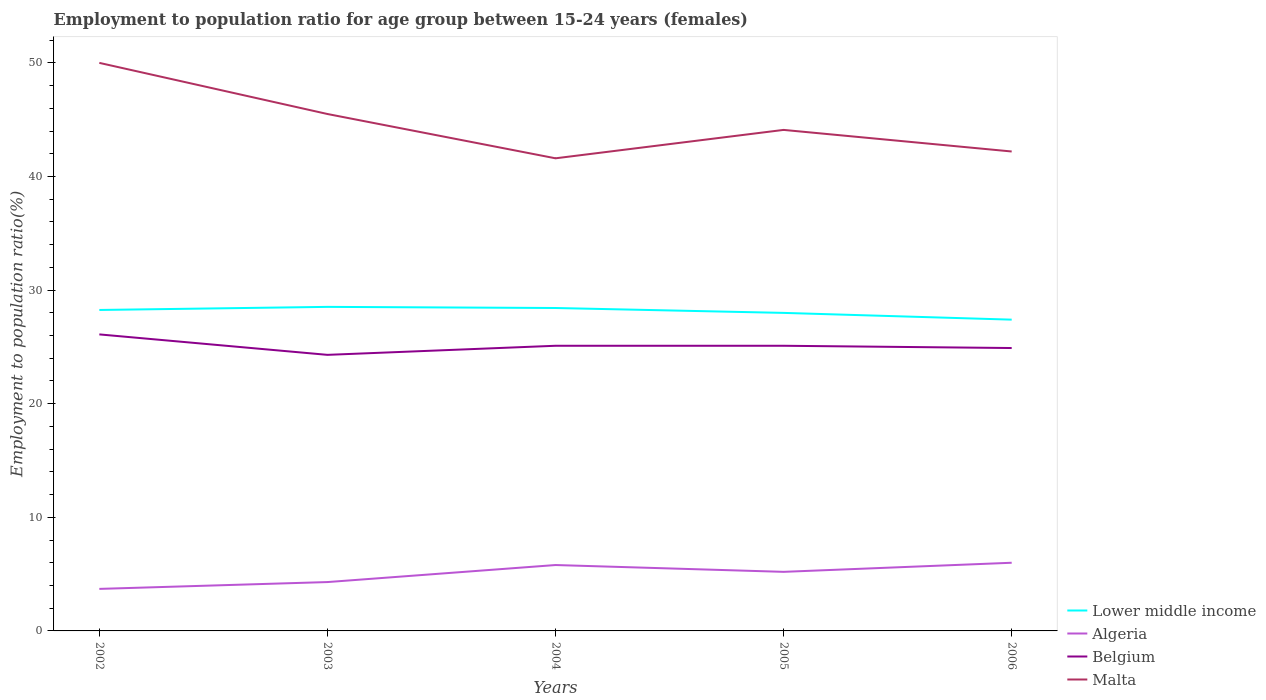How many different coloured lines are there?
Your response must be concise. 4. Across all years, what is the maximum employment to population ratio in Malta?
Keep it short and to the point. 41.6. In which year was the employment to population ratio in Belgium maximum?
Your answer should be compact. 2003. What is the total employment to population ratio in Belgium in the graph?
Offer a terse response. -0.8. What is the difference between the highest and the second highest employment to population ratio in Lower middle income?
Ensure brevity in your answer.  1.12. What is the difference between the highest and the lowest employment to population ratio in Malta?
Provide a succinct answer. 2. Is the employment to population ratio in Belgium strictly greater than the employment to population ratio in Algeria over the years?
Offer a very short reply. No. How many lines are there?
Keep it short and to the point. 4. What is the difference between two consecutive major ticks on the Y-axis?
Give a very brief answer. 10. Are the values on the major ticks of Y-axis written in scientific E-notation?
Keep it short and to the point. No. Does the graph contain any zero values?
Provide a short and direct response. No. Does the graph contain grids?
Offer a terse response. No. How many legend labels are there?
Your answer should be compact. 4. What is the title of the graph?
Make the answer very short. Employment to population ratio for age group between 15-24 years (females). What is the label or title of the X-axis?
Your response must be concise. Years. What is the label or title of the Y-axis?
Your answer should be very brief. Employment to population ratio(%). What is the Employment to population ratio(%) in Lower middle income in 2002?
Offer a terse response. 28.25. What is the Employment to population ratio(%) of Algeria in 2002?
Your answer should be very brief. 3.7. What is the Employment to population ratio(%) of Belgium in 2002?
Your response must be concise. 26.1. What is the Employment to population ratio(%) in Malta in 2002?
Your answer should be very brief. 50. What is the Employment to population ratio(%) of Lower middle income in 2003?
Offer a very short reply. 28.52. What is the Employment to population ratio(%) in Algeria in 2003?
Make the answer very short. 4.3. What is the Employment to population ratio(%) in Belgium in 2003?
Your response must be concise. 24.3. What is the Employment to population ratio(%) in Malta in 2003?
Your response must be concise. 45.5. What is the Employment to population ratio(%) of Lower middle income in 2004?
Make the answer very short. 28.42. What is the Employment to population ratio(%) of Algeria in 2004?
Offer a terse response. 5.8. What is the Employment to population ratio(%) in Belgium in 2004?
Keep it short and to the point. 25.1. What is the Employment to population ratio(%) of Malta in 2004?
Ensure brevity in your answer.  41.6. What is the Employment to population ratio(%) of Lower middle income in 2005?
Give a very brief answer. 27.99. What is the Employment to population ratio(%) of Algeria in 2005?
Your response must be concise. 5.2. What is the Employment to population ratio(%) in Belgium in 2005?
Your answer should be very brief. 25.1. What is the Employment to population ratio(%) in Malta in 2005?
Offer a terse response. 44.1. What is the Employment to population ratio(%) of Lower middle income in 2006?
Provide a short and direct response. 27.4. What is the Employment to population ratio(%) of Algeria in 2006?
Offer a very short reply. 6. What is the Employment to population ratio(%) of Belgium in 2006?
Ensure brevity in your answer.  24.9. What is the Employment to population ratio(%) of Malta in 2006?
Ensure brevity in your answer.  42.2. Across all years, what is the maximum Employment to population ratio(%) in Lower middle income?
Provide a succinct answer. 28.52. Across all years, what is the maximum Employment to population ratio(%) of Belgium?
Offer a terse response. 26.1. Across all years, what is the minimum Employment to population ratio(%) of Lower middle income?
Your answer should be very brief. 27.4. Across all years, what is the minimum Employment to population ratio(%) in Algeria?
Your answer should be compact. 3.7. Across all years, what is the minimum Employment to population ratio(%) in Belgium?
Provide a short and direct response. 24.3. Across all years, what is the minimum Employment to population ratio(%) of Malta?
Your answer should be very brief. 41.6. What is the total Employment to population ratio(%) in Lower middle income in the graph?
Offer a terse response. 140.59. What is the total Employment to population ratio(%) in Belgium in the graph?
Keep it short and to the point. 125.5. What is the total Employment to population ratio(%) of Malta in the graph?
Provide a succinct answer. 223.4. What is the difference between the Employment to population ratio(%) of Lower middle income in 2002 and that in 2003?
Offer a terse response. -0.27. What is the difference between the Employment to population ratio(%) in Malta in 2002 and that in 2003?
Provide a short and direct response. 4.5. What is the difference between the Employment to population ratio(%) in Lower middle income in 2002 and that in 2004?
Your answer should be compact. -0.17. What is the difference between the Employment to population ratio(%) of Algeria in 2002 and that in 2004?
Provide a succinct answer. -2.1. What is the difference between the Employment to population ratio(%) in Belgium in 2002 and that in 2004?
Provide a short and direct response. 1. What is the difference between the Employment to population ratio(%) in Lower middle income in 2002 and that in 2005?
Make the answer very short. 0.26. What is the difference between the Employment to population ratio(%) in Lower middle income in 2002 and that in 2006?
Offer a very short reply. 0.85. What is the difference between the Employment to population ratio(%) in Algeria in 2002 and that in 2006?
Your answer should be compact. -2.3. What is the difference between the Employment to population ratio(%) of Belgium in 2002 and that in 2006?
Make the answer very short. 1.2. What is the difference between the Employment to population ratio(%) in Lower middle income in 2003 and that in 2004?
Offer a very short reply. 0.1. What is the difference between the Employment to population ratio(%) of Belgium in 2003 and that in 2004?
Your answer should be very brief. -0.8. What is the difference between the Employment to population ratio(%) of Lower middle income in 2003 and that in 2005?
Ensure brevity in your answer.  0.53. What is the difference between the Employment to population ratio(%) of Belgium in 2003 and that in 2005?
Provide a succinct answer. -0.8. What is the difference between the Employment to population ratio(%) in Lower middle income in 2003 and that in 2006?
Offer a terse response. 1.12. What is the difference between the Employment to population ratio(%) in Lower middle income in 2004 and that in 2005?
Ensure brevity in your answer.  0.43. What is the difference between the Employment to population ratio(%) in Belgium in 2004 and that in 2005?
Provide a succinct answer. 0. What is the difference between the Employment to population ratio(%) of Malta in 2004 and that in 2005?
Provide a short and direct response. -2.5. What is the difference between the Employment to population ratio(%) of Lower middle income in 2004 and that in 2006?
Your answer should be very brief. 1.02. What is the difference between the Employment to population ratio(%) of Malta in 2004 and that in 2006?
Ensure brevity in your answer.  -0.6. What is the difference between the Employment to population ratio(%) in Lower middle income in 2005 and that in 2006?
Keep it short and to the point. 0.59. What is the difference between the Employment to population ratio(%) in Algeria in 2005 and that in 2006?
Your response must be concise. -0.8. What is the difference between the Employment to population ratio(%) in Belgium in 2005 and that in 2006?
Make the answer very short. 0.2. What is the difference between the Employment to population ratio(%) of Malta in 2005 and that in 2006?
Your answer should be compact. 1.9. What is the difference between the Employment to population ratio(%) in Lower middle income in 2002 and the Employment to population ratio(%) in Algeria in 2003?
Your response must be concise. 23.95. What is the difference between the Employment to population ratio(%) in Lower middle income in 2002 and the Employment to population ratio(%) in Belgium in 2003?
Keep it short and to the point. 3.95. What is the difference between the Employment to population ratio(%) of Lower middle income in 2002 and the Employment to population ratio(%) of Malta in 2003?
Your answer should be compact. -17.25. What is the difference between the Employment to population ratio(%) in Algeria in 2002 and the Employment to population ratio(%) in Belgium in 2003?
Offer a terse response. -20.6. What is the difference between the Employment to population ratio(%) of Algeria in 2002 and the Employment to population ratio(%) of Malta in 2003?
Keep it short and to the point. -41.8. What is the difference between the Employment to population ratio(%) in Belgium in 2002 and the Employment to population ratio(%) in Malta in 2003?
Keep it short and to the point. -19.4. What is the difference between the Employment to population ratio(%) in Lower middle income in 2002 and the Employment to population ratio(%) in Algeria in 2004?
Give a very brief answer. 22.45. What is the difference between the Employment to population ratio(%) of Lower middle income in 2002 and the Employment to population ratio(%) of Belgium in 2004?
Provide a short and direct response. 3.15. What is the difference between the Employment to population ratio(%) in Lower middle income in 2002 and the Employment to population ratio(%) in Malta in 2004?
Ensure brevity in your answer.  -13.35. What is the difference between the Employment to population ratio(%) in Algeria in 2002 and the Employment to population ratio(%) in Belgium in 2004?
Offer a terse response. -21.4. What is the difference between the Employment to population ratio(%) of Algeria in 2002 and the Employment to population ratio(%) of Malta in 2004?
Offer a very short reply. -37.9. What is the difference between the Employment to population ratio(%) in Belgium in 2002 and the Employment to population ratio(%) in Malta in 2004?
Make the answer very short. -15.5. What is the difference between the Employment to population ratio(%) of Lower middle income in 2002 and the Employment to population ratio(%) of Algeria in 2005?
Keep it short and to the point. 23.05. What is the difference between the Employment to population ratio(%) in Lower middle income in 2002 and the Employment to population ratio(%) in Belgium in 2005?
Your answer should be very brief. 3.15. What is the difference between the Employment to population ratio(%) of Lower middle income in 2002 and the Employment to population ratio(%) of Malta in 2005?
Give a very brief answer. -15.85. What is the difference between the Employment to population ratio(%) in Algeria in 2002 and the Employment to population ratio(%) in Belgium in 2005?
Offer a very short reply. -21.4. What is the difference between the Employment to population ratio(%) of Algeria in 2002 and the Employment to population ratio(%) of Malta in 2005?
Provide a short and direct response. -40.4. What is the difference between the Employment to population ratio(%) in Lower middle income in 2002 and the Employment to population ratio(%) in Algeria in 2006?
Your answer should be compact. 22.25. What is the difference between the Employment to population ratio(%) of Lower middle income in 2002 and the Employment to population ratio(%) of Belgium in 2006?
Offer a very short reply. 3.35. What is the difference between the Employment to population ratio(%) of Lower middle income in 2002 and the Employment to population ratio(%) of Malta in 2006?
Provide a short and direct response. -13.95. What is the difference between the Employment to population ratio(%) of Algeria in 2002 and the Employment to population ratio(%) of Belgium in 2006?
Your answer should be very brief. -21.2. What is the difference between the Employment to population ratio(%) in Algeria in 2002 and the Employment to population ratio(%) in Malta in 2006?
Ensure brevity in your answer.  -38.5. What is the difference between the Employment to population ratio(%) in Belgium in 2002 and the Employment to population ratio(%) in Malta in 2006?
Keep it short and to the point. -16.1. What is the difference between the Employment to population ratio(%) of Lower middle income in 2003 and the Employment to population ratio(%) of Algeria in 2004?
Your answer should be compact. 22.72. What is the difference between the Employment to population ratio(%) of Lower middle income in 2003 and the Employment to population ratio(%) of Belgium in 2004?
Offer a very short reply. 3.42. What is the difference between the Employment to population ratio(%) in Lower middle income in 2003 and the Employment to population ratio(%) in Malta in 2004?
Your answer should be very brief. -13.08. What is the difference between the Employment to population ratio(%) of Algeria in 2003 and the Employment to population ratio(%) of Belgium in 2004?
Keep it short and to the point. -20.8. What is the difference between the Employment to population ratio(%) in Algeria in 2003 and the Employment to population ratio(%) in Malta in 2004?
Your answer should be compact. -37.3. What is the difference between the Employment to population ratio(%) in Belgium in 2003 and the Employment to population ratio(%) in Malta in 2004?
Ensure brevity in your answer.  -17.3. What is the difference between the Employment to population ratio(%) of Lower middle income in 2003 and the Employment to population ratio(%) of Algeria in 2005?
Ensure brevity in your answer.  23.32. What is the difference between the Employment to population ratio(%) of Lower middle income in 2003 and the Employment to population ratio(%) of Belgium in 2005?
Your answer should be compact. 3.42. What is the difference between the Employment to population ratio(%) of Lower middle income in 2003 and the Employment to population ratio(%) of Malta in 2005?
Offer a terse response. -15.58. What is the difference between the Employment to population ratio(%) of Algeria in 2003 and the Employment to population ratio(%) of Belgium in 2005?
Ensure brevity in your answer.  -20.8. What is the difference between the Employment to population ratio(%) in Algeria in 2003 and the Employment to population ratio(%) in Malta in 2005?
Make the answer very short. -39.8. What is the difference between the Employment to population ratio(%) in Belgium in 2003 and the Employment to population ratio(%) in Malta in 2005?
Ensure brevity in your answer.  -19.8. What is the difference between the Employment to population ratio(%) in Lower middle income in 2003 and the Employment to population ratio(%) in Algeria in 2006?
Keep it short and to the point. 22.52. What is the difference between the Employment to population ratio(%) in Lower middle income in 2003 and the Employment to population ratio(%) in Belgium in 2006?
Offer a very short reply. 3.62. What is the difference between the Employment to population ratio(%) of Lower middle income in 2003 and the Employment to population ratio(%) of Malta in 2006?
Keep it short and to the point. -13.68. What is the difference between the Employment to population ratio(%) of Algeria in 2003 and the Employment to population ratio(%) of Belgium in 2006?
Provide a succinct answer. -20.6. What is the difference between the Employment to population ratio(%) of Algeria in 2003 and the Employment to population ratio(%) of Malta in 2006?
Your answer should be very brief. -37.9. What is the difference between the Employment to population ratio(%) in Belgium in 2003 and the Employment to population ratio(%) in Malta in 2006?
Make the answer very short. -17.9. What is the difference between the Employment to population ratio(%) in Lower middle income in 2004 and the Employment to population ratio(%) in Algeria in 2005?
Ensure brevity in your answer.  23.22. What is the difference between the Employment to population ratio(%) in Lower middle income in 2004 and the Employment to population ratio(%) in Belgium in 2005?
Ensure brevity in your answer.  3.32. What is the difference between the Employment to population ratio(%) in Lower middle income in 2004 and the Employment to population ratio(%) in Malta in 2005?
Make the answer very short. -15.68. What is the difference between the Employment to population ratio(%) in Algeria in 2004 and the Employment to population ratio(%) in Belgium in 2005?
Provide a succinct answer. -19.3. What is the difference between the Employment to population ratio(%) in Algeria in 2004 and the Employment to population ratio(%) in Malta in 2005?
Keep it short and to the point. -38.3. What is the difference between the Employment to population ratio(%) of Belgium in 2004 and the Employment to population ratio(%) of Malta in 2005?
Provide a short and direct response. -19. What is the difference between the Employment to population ratio(%) of Lower middle income in 2004 and the Employment to population ratio(%) of Algeria in 2006?
Provide a short and direct response. 22.42. What is the difference between the Employment to population ratio(%) of Lower middle income in 2004 and the Employment to population ratio(%) of Belgium in 2006?
Ensure brevity in your answer.  3.52. What is the difference between the Employment to population ratio(%) of Lower middle income in 2004 and the Employment to population ratio(%) of Malta in 2006?
Keep it short and to the point. -13.78. What is the difference between the Employment to population ratio(%) of Algeria in 2004 and the Employment to population ratio(%) of Belgium in 2006?
Provide a succinct answer. -19.1. What is the difference between the Employment to population ratio(%) in Algeria in 2004 and the Employment to population ratio(%) in Malta in 2006?
Your response must be concise. -36.4. What is the difference between the Employment to population ratio(%) in Belgium in 2004 and the Employment to population ratio(%) in Malta in 2006?
Offer a terse response. -17.1. What is the difference between the Employment to population ratio(%) of Lower middle income in 2005 and the Employment to population ratio(%) of Algeria in 2006?
Your answer should be very brief. 21.99. What is the difference between the Employment to population ratio(%) in Lower middle income in 2005 and the Employment to population ratio(%) in Belgium in 2006?
Make the answer very short. 3.09. What is the difference between the Employment to population ratio(%) in Lower middle income in 2005 and the Employment to population ratio(%) in Malta in 2006?
Offer a very short reply. -14.21. What is the difference between the Employment to population ratio(%) in Algeria in 2005 and the Employment to population ratio(%) in Belgium in 2006?
Your answer should be very brief. -19.7. What is the difference between the Employment to population ratio(%) in Algeria in 2005 and the Employment to population ratio(%) in Malta in 2006?
Your response must be concise. -37. What is the difference between the Employment to population ratio(%) of Belgium in 2005 and the Employment to population ratio(%) of Malta in 2006?
Offer a very short reply. -17.1. What is the average Employment to population ratio(%) of Lower middle income per year?
Offer a very short reply. 28.12. What is the average Employment to population ratio(%) of Belgium per year?
Your answer should be compact. 25.1. What is the average Employment to population ratio(%) of Malta per year?
Offer a terse response. 44.68. In the year 2002, what is the difference between the Employment to population ratio(%) in Lower middle income and Employment to population ratio(%) in Algeria?
Provide a short and direct response. 24.55. In the year 2002, what is the difference between the Employment to population ratio(%) in Lower middle income and Employment to population ratio(%) in Belgium?
Make the answer very short. 2.15. In the year 2002, what is the difference between the Employment to population ratio(%) of Lower middle income and Employment to population ratio(%) of Malta?
Provide a succinct answer. -21.75. In the year 2002, what is the difference between the Employment to population ratio(%) of Algeria and Employment to population ratio(%) of Belgium?
Offer a terse response. -22.4. In the year 2002, what is the difference between the Employment to population ratio(%) in Algeria and Employment to population ratio(%) in Malta?
Make the answer very short. -46.3. In the year 2002, what is the difference between the Employment to population ratio(%) of Belgium and Employment to population ratio(%) of Malta?
Ensure brevity in your answer.  -23.9. In the year 2003, what is the difference between the Employment to population ratio(%) of Lower middle income and Employment to population ratio(%) of Algeria?
Ensure brevity in your answer.  24.22. In the year 2003, what is the difference between the Employment to population ratio(%) in Lower middle income and Employment to population ratio(%) in Belgium?
Ensure brevity in your answer.  4.22. In the year 2003, what is the difference between the Employment to population ratio(%) of Lower middle income and Employment to population ratio(%) of Malta?
Offer a terse response. -16.98. In the year 2003, what is the difference between the Employment to population ratio(%) of Algeria and Employment to population ratio(%) of Malta?
Offer a terse response. -41.2. In the year 2003, what is the difference between the Employment to population ratio(%) in Belgium and Employment to population ratio(%) in Malta?
Your response must be concise. -21.2. In the year 2004, what is the difference between the Employment to population ratio(%) in Lower middle income and Employment to population ratio(%) in Algeria?
Your response must be concise. 22.62. In the year 2004, what is the difference between the Employment to population ratio(%) of Lower middle income and Employment to population ratio(%) of Belgium?
Provide a succinct answer. 3.32. In the year 2004, what is the difference between the Employment to population ratio(%) of Lower middle income and Employment to population ratio(%) of Malta?
Offer a very short reply. -13.18. In the year 2004, what is the difference between the Employment to population ratio(%) in Algeria and Employment to population ratio(%) in Belgium?
Your response must be concise. -19.3. In the year 2004, what is the difference between the Employment to population ratio(%) in Algeria and Employment to population ratio(%) in Malta?
Keep it short and to the point. -35.8. In the year 2004, what is the difference between the Employment to population ratio(%) of Belgium and Employment to population ratio(%) of Malta?
Your response must be concise. -16.5. In the year 2005, what is the difference between the Employment to population ratio(%) in Lower middle income and Employment to population ratio(%) in Algeria?
Offer a terse response. 22.79. In the year 2005, what is the difference between the Employment to population ratio(%) of Lower middle income and Employment to population ratio(%) of Belgium?
Give a very brief answer. 2.89. In the year 2005, what is the difference between the Employment to population ratio(%) in Lower middle income and Employment to population ratio(%) in Malta?
Give a very brief answer. -16.11. In the year 2005, what is the difference between the Employment to population ratio(%) in Algeria and Employment to population ratio(%) in Belgium?
Provide a succinct answer. -19.9. In the year 2005, what is the difference between the Employment to population ratio(%) in Algeria and Employment to population ratio(%) in Malta?
Provide a short and direct response. -38.9. In the year 2006, what is the difference between the Employment to population ratio(%) of Lower middle income and Employment to population ratio(%) of Algeria?
Offer a very short reply. 21.4. In the year 2006, what is the difference between the Employment to population ratio(%) of Lower middle income and Employment to population ratio(%) of Belgium?
Provide a succinct answer. 2.5. In the year 2006, what is the difference between the Employment to population ratio(%) in Lower middle income and Employment to population ratio(%) in Malta?
Ensure brevity in your answer.  -14.8. In the year 2006, what is the difference between the Employment to population ratio(%) in Algeria and Employment to population ratio(%) in Belgium?
Your response must be concise. -18.9. In the year 2006, what is the difference between the Employment to population ratio(%) of Algeria and Employment to population ratio(%) of Malta?
Your answer should be very brief. -36.2. In the year 2006, what is the difference between the Employment to population ratio(%) of Belgium and Employment to population ratio(%) of Malta?
Keep it short and to the point. -17.3. What is the ratio of the Employment to population ratio(%) in Lower middle income in 2002 to that in 2003?
Your answer should be compact. 0.99. What is the ratio of the Employment to population ratio(%) of Algeria in 2002 to that in 2003?
Give a very brief answer. 0.86. What is the ratio of the Employment to population ratio(%) of Belgium in 2002 to that in 2003?
Keep it short and to the point. 1.07. What is the ratio of the Employment to population ratio(%) of Malta in 2002 to that in 2003?
Your answer should be compact. 1.1. What is the ratio of the Employment to population ratio(%) in Algeria in 2002 to that in 2004?
Provide a short and direct response. 0.64. What is the ratio of the Employment to population ratio(%) of Belgium in 2002 to that in 2004?
Ensure brevity in your answer.  1.04. What is the ratio of the Employment to population ratio(%) in Malta in 2002 to that in 2004?
Your answer should be compact. 1.2. What is the ratio of the Employment to population ratio(%) of Lower middle income in 2002 to that in 2005?
Give a very brief answer. 1.01. What is the ratio of the Employment to population ratio(%) of Algeria in 2002 to that in 2005?
Offer a very short reply. 0.71. What is the ratio of the Employment to population ratio(%) in Belgium in 2002 to that in 2005?
Ensure brevity in your answer.  1.04. What is the ratio of the Employment to population ratio(%) in Malta in 2002 to that in 2005?
Your response must be concise. 1.13. What is the ratio of the Employment to population ratio(%) of Lower middle income in 2002 to that in 2006?
Provide a short and direct response. 1.03. What is the ratio of the Employment to population ratio(%) of Algeria in 2002 to that in 2006?
Offer a terse response. 0.62. What is the ratio of the Employment to population ratio(%) of Belgium in 2002 to that in 2006?
Make the answer very short. 1.05. What is the ratio of the Employment to population ratio(%) in Malta in 2002 to that in 2006?
Your answer should be very brief. 1.18. What is the ratio of the Employment to population ratio(%) in Algeria in 2003 to that in 2004?
Your answer should be very brief. 0.74. What is the ratio of the Employment to population ratio(%) of Belgium in 2003 to that in 2004?
Offer a terse response. 0.97. What is the ratio of the Employment to population ratio(%) of Malta in 2003 to that in 2004?
Provide a succinct answer. 1.09. What is the ratio of the Employment to population ratio(%) in Lower middle income in 2003 to that in 2005?
Give a very brief answer. 1.02. What is the ratio of the Employment to population ratio(%) of Algeria in 2003 to that in 2005?
Offer a terse response. 0.83. What is the ratio of the Employment to population ratio(%) in Belgium in 2003 to that in 2005?
Your answer should be compact. 0.97. What is the ratio of the Employment to population ratio(%) in Malta in 2003 to that in 2005?
Give a very brief answer. 1.03. What is the ratio of the Employment to population ratio(%) in Lower middle income in 2003 to that in 2006?
Give a very brief answer. 1.04. What is the ratio of the Employment to population ratio(%) of Algeria in 2003 to that in 2006?
Your response must be concise. 0.72. What is the ratio of the Employment to population ratio(%) in Belgium in 2003 to that in 2006?
Offer a very short reply. 0.98. What is the ratio of the Employment to population ratio(%) in Malta in 2003 to that in 2006?
Provide a short and direct response. 1.08. What is the ratio of the Employment to population ratio(%) of Lower middle income in 2004 to that in 2005?
Your answer should be compact. 1.02. What is the ratio of the Employment to population ratio(%) in Algeria in 2004 to that in 2005?
Keep it short and to the point. 1.12. What is the ratio of the Employment to population ratio(%) in Belgium in 2004 to that in 2005?
Provide a succinct answer. 1. What is the ratio of the Employment to population ratio(%) of Malta in 2004 to that in 2005?
Offer a terse response. 0.94. What is the ratio of the Employment to population ratio(%) of Lower middle income in 2004 to that in 2006?
Keep it short and to the point. 1.04. What is the ratio of the Employment to population ratio(%) of Algeria in 2004 to that in 2006?
Your answer should be compact. 0.97. What is the ratio of the Employment to population ratio(%) in Malta in 2004 to that in 2006?
Ensure brevity in your answer.  0.99. What is the ratio of the Employment to population ratio(%) in Lower middle income in 2005 to that in 2006?
Provide a short and direct response. 1.02. What is the ratio of the Employment to population ratio(%) of Algeria in 2005 to that in 2006?
Your answer should be compact. 0.87. What is the ratio of the Employment to population ratio(%) in Malta in 2005 to that in 2006?
Ensure brevity in your answer.  1.04. What is the difference between the highest and the second highest Employment to population ratio(%) in Lower middle income?
Your answer should be compact. 0.1. What is the difference between the highest and the second highest Employment to population ratio(%) of Algeria?
Make the answer very short. 0.2. What is the difference between the highest and the second highest Employment to population ratio(%) of Malta?
Keep it short and to the point. 4.5. What is the difference between the highest and the lowest Employment to population ratio(%) of Lower middle income?
Your answer should be compact. 1.12. What is the difference between the highest and the lowest Employment to population ratio(%) of Malta?
Offer a terse response. 8.4. 